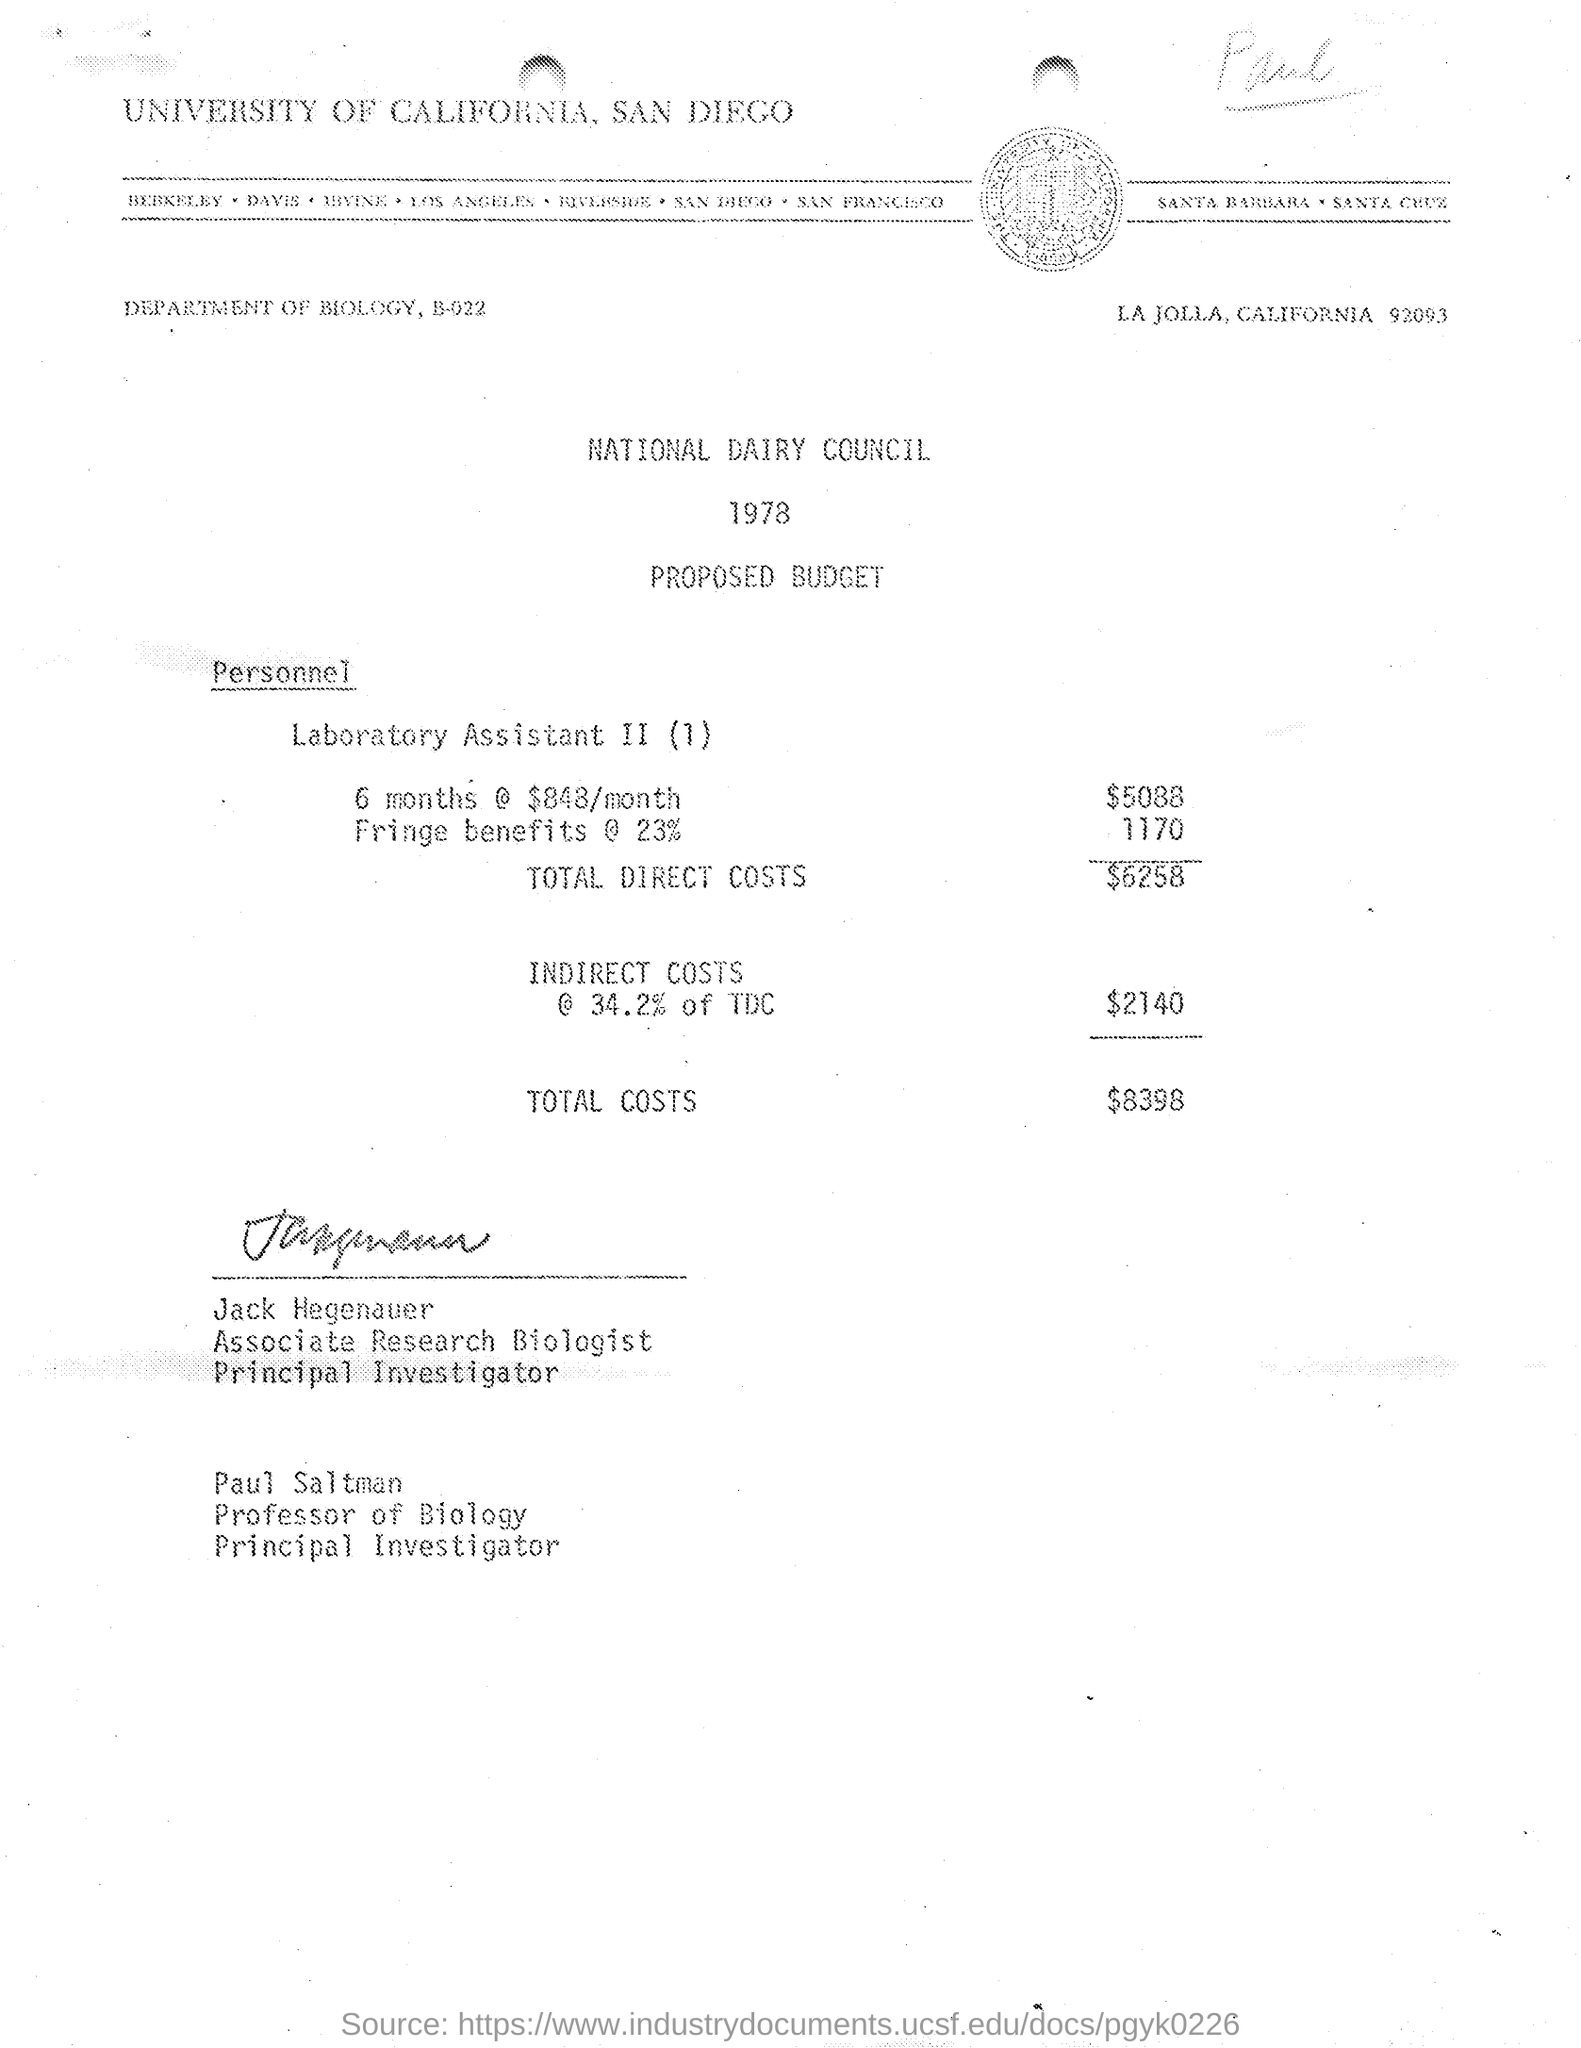Who are the principal investigators listed in this budget document? The principal investigators listed in the budget document are Jack Hegenauer, who is an Associate Research Biologist, and Paul Saltman, a Professor of Biology. 